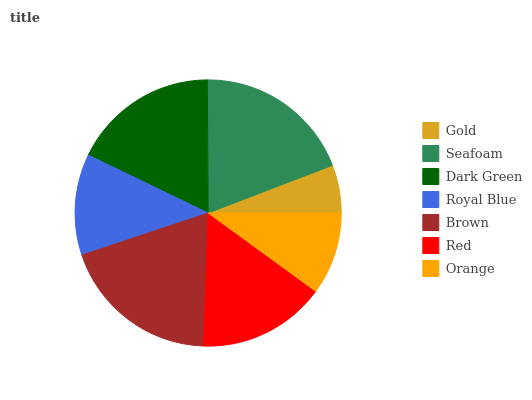Is Gold the minimum?
Answer yes or no. Yes. Is Brown the maximum?
Answer yes or no. Yes. Is Seafoam the minimum?
Answer yes or no. No. Is Seafoam the maximum?
Answer yes or no. No. Is Seafoam greater than Gold?
Answer yes or no. Yes. Is Gold less than Seafoam?
Answer yes or no. Yes. Is Gold greater than Seafoam?
Answer yes or no. No. Is Seafoam less than Gold?
Answer yes or no. No. Is Red the high median?
Answer yes or no. Yes. Is Red the low median?
Answer yes or no. Yes. Is Orange the high median?
Answer yes or no. No. Is Brown the low median?
Answer yes or no. No. 